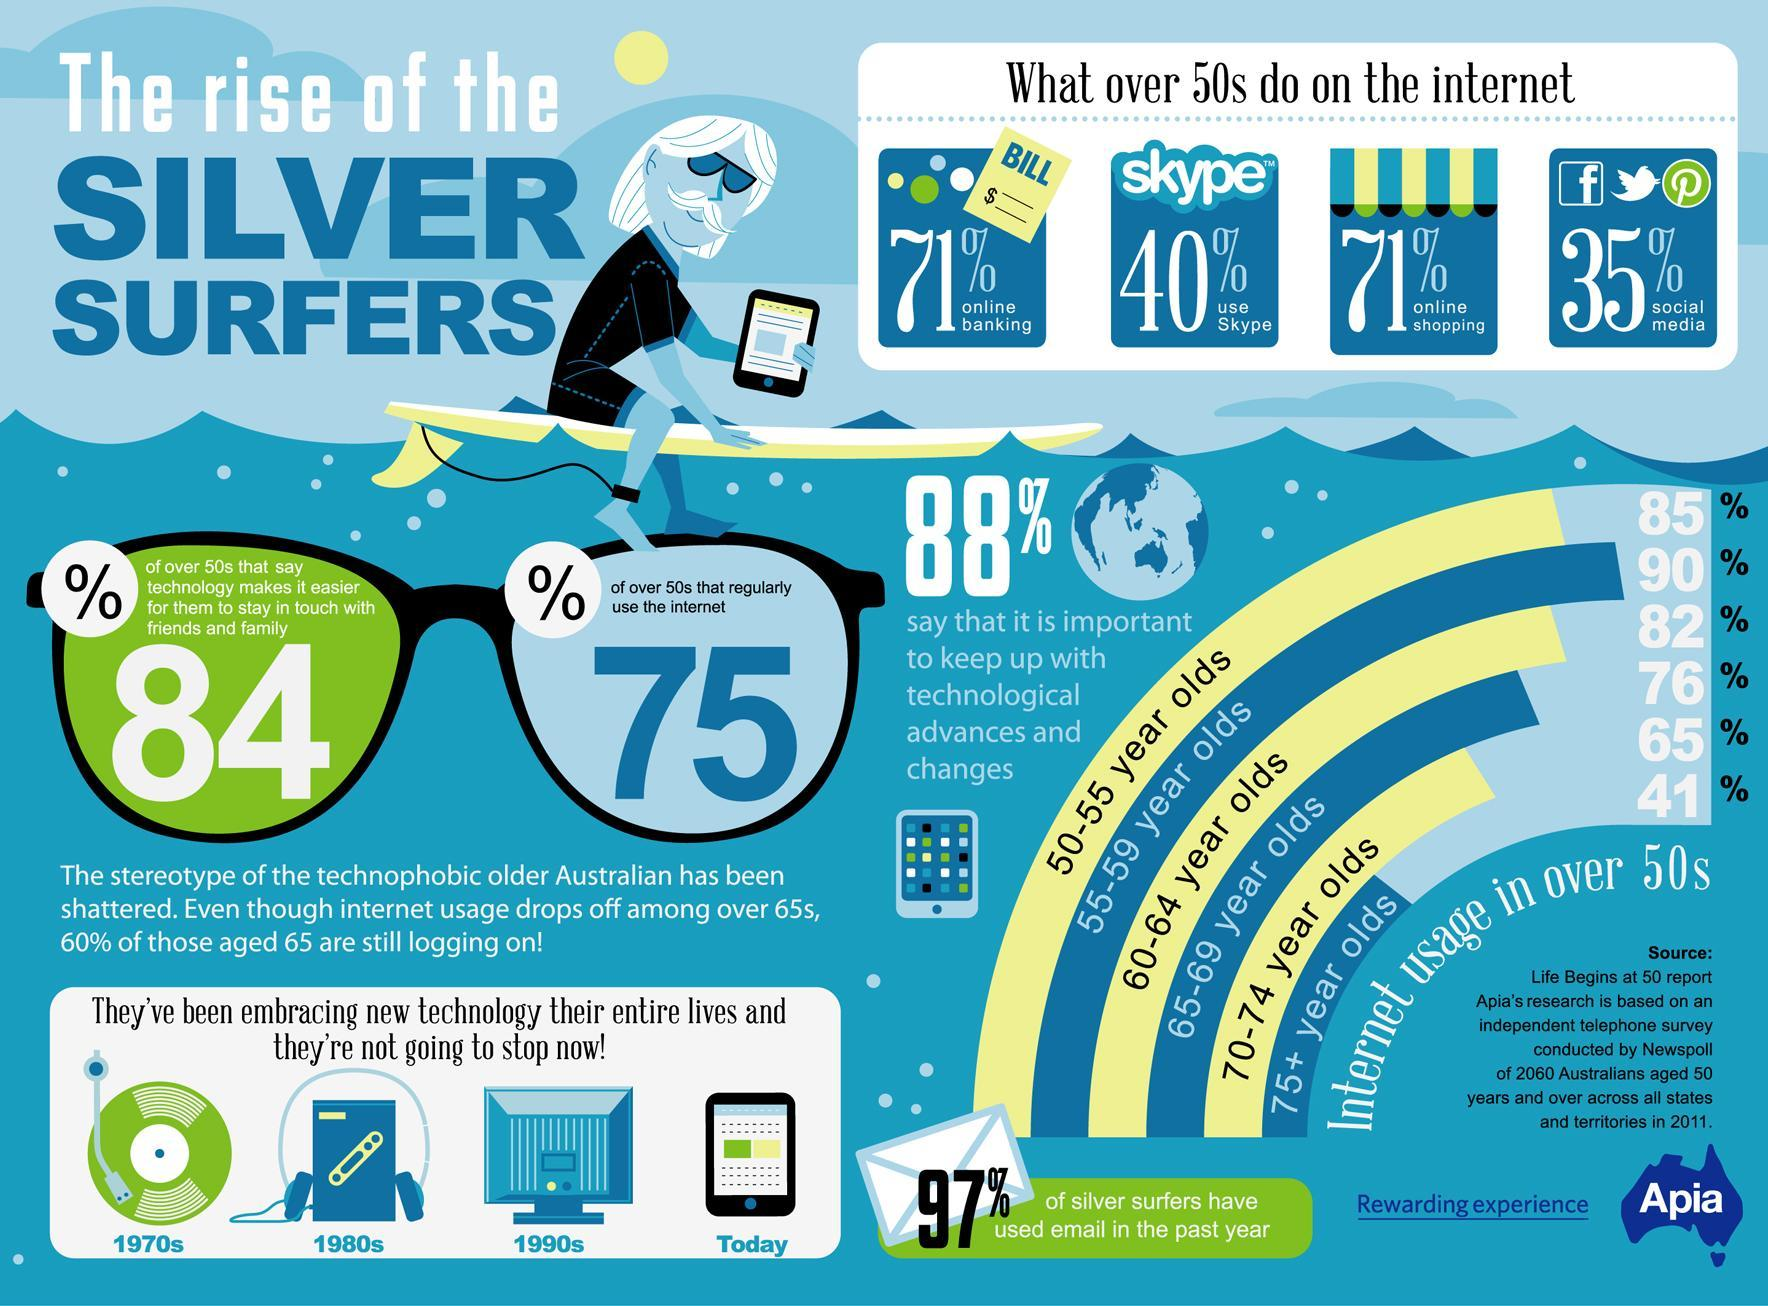What percent of Australians aged over 50 regularly use the internet according to the 2011 survey?
Answer the question with a short phrase. 75 What percent of Australians aged 60-64 years use the internet according to the 2011 survey? 82% What percent of Australians aged 70-74 years use the internet according to the 2011 survey? 65% What percent of Australians aged over 50 do online shopping as per the 2011 survey? 71% What percent of Australians aged over 50 say that it is not important to keep up with technological advances & changes according to the 2011 survey? 12% What percent of Australians aged over 50 use social media as per the 2011 survey? 35% What percent of Australians aged 55-59 years use the internet according to the 2011 survey? 90% 